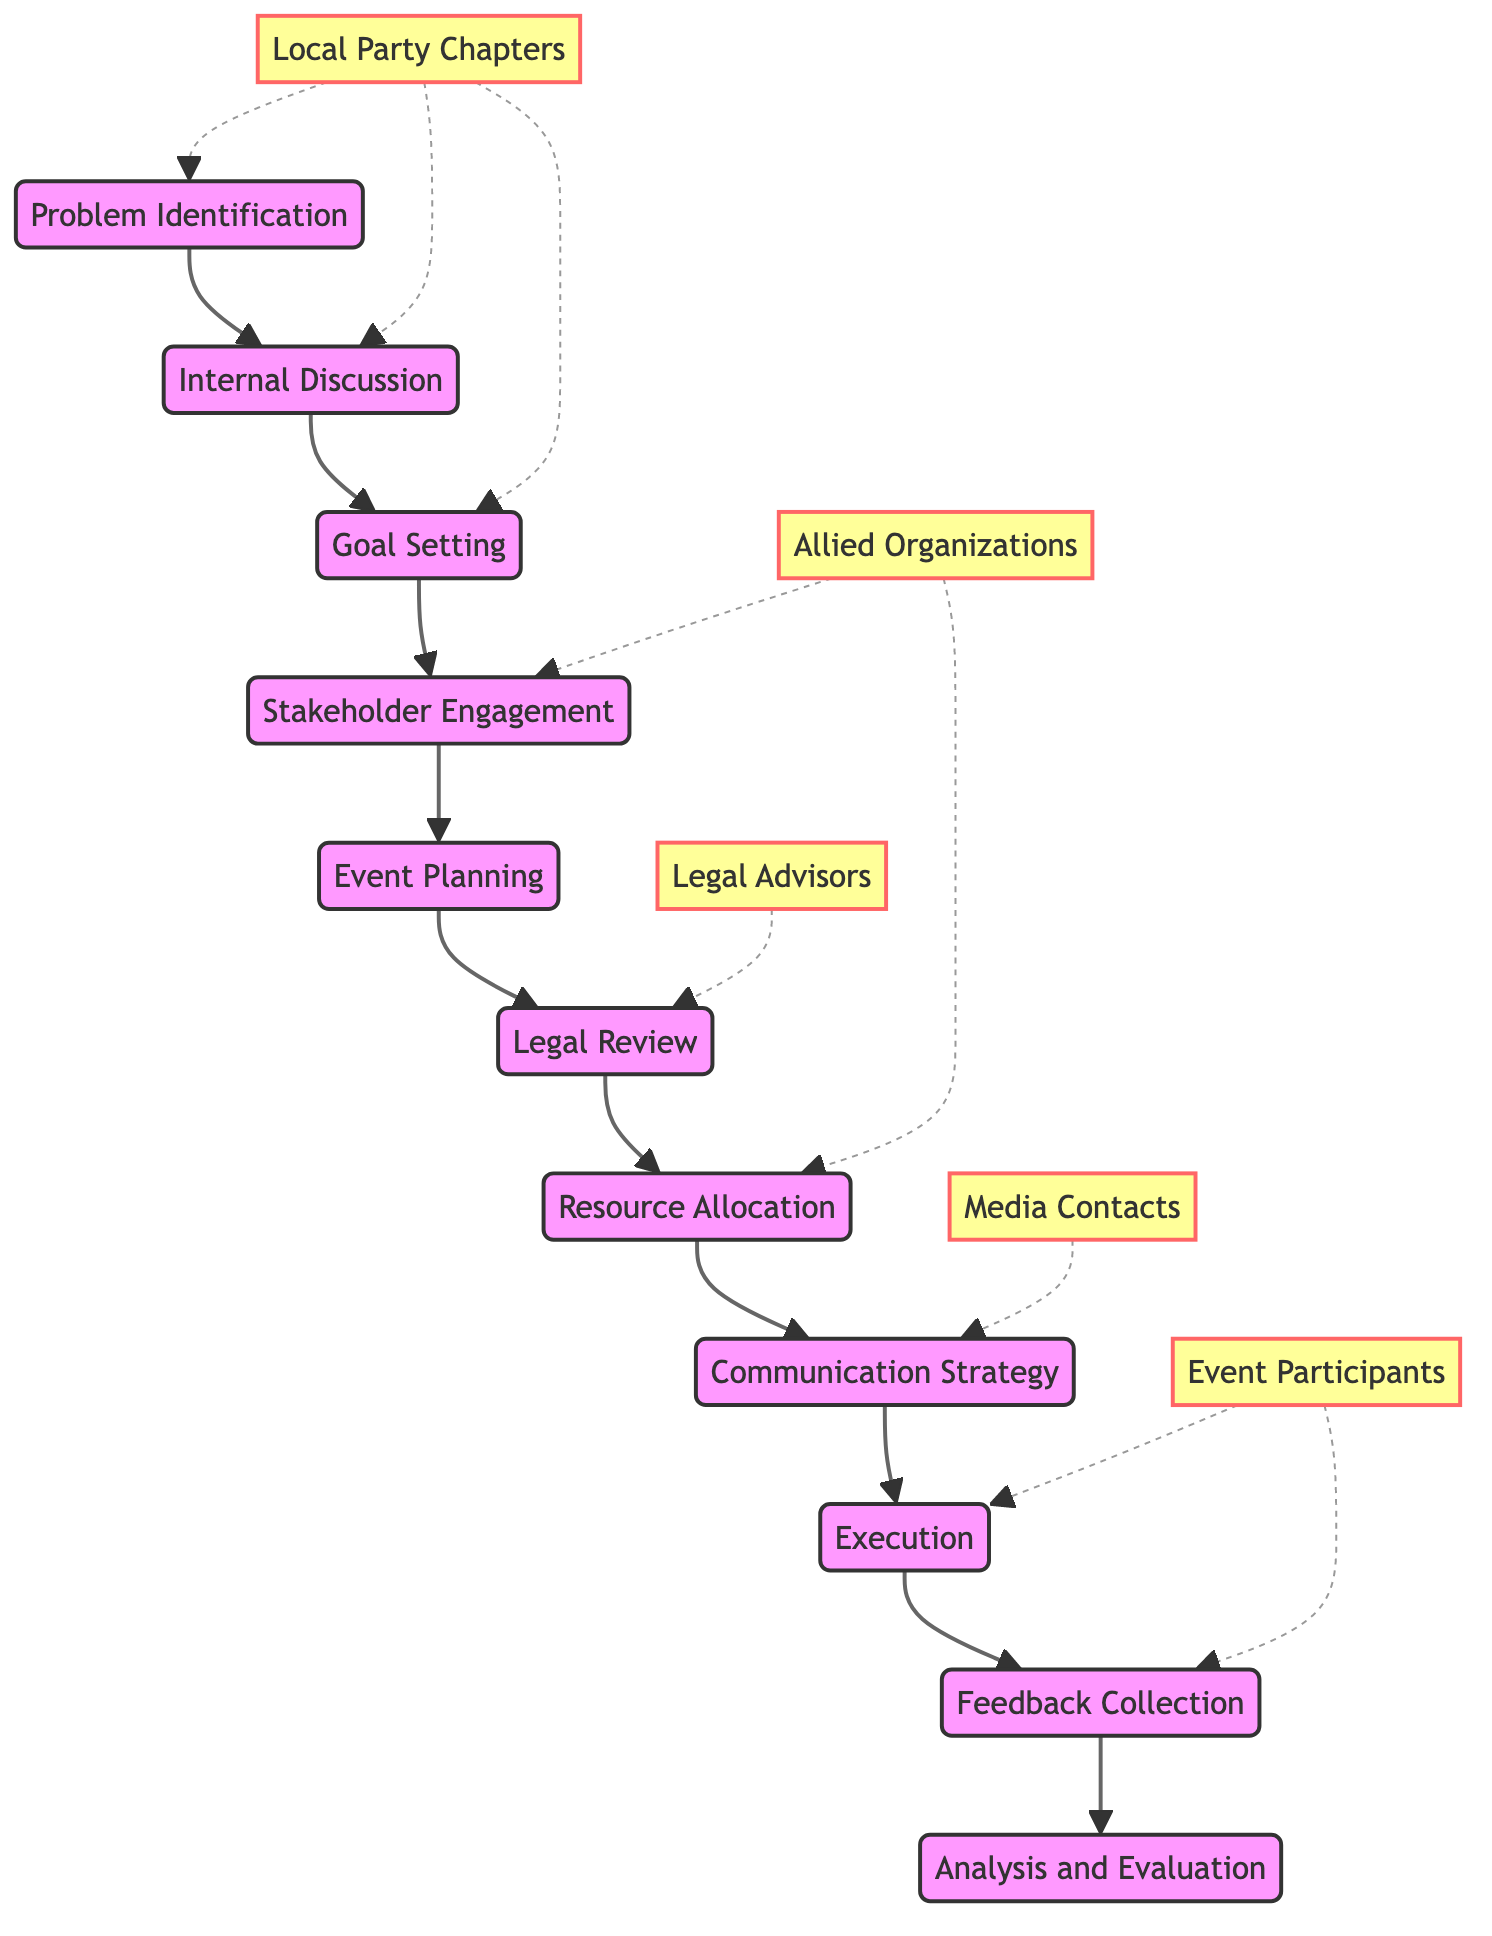What is the first step in the decision-making process? The first step, as represented by the diagram, is "Problem Identification". This is determined by looking at the starting node before any edges leading to other nodes.
Answer: Problem Identification How many stakeholders are involved in this process? By counting the distinct stakeholders listed in the diagram, there are five entities: "Local Party Chapters", "Allied Organizations", "Legal Advisors", "Media Contacts", and "Event Participants".
Answer: Five What is the last stage in the flow of the decision-making process? The last stage can be identified by following the directed edges from the first node all the way to the terminal node, which is "Analysis and Evaluation".
Answer: Analysis and Evaluation Which stakeholders are involved in the "Execution" stage? The diagram indicates that the stakeholder "Event Participants" is connected to the node "Execution", showing their involvement at this stage of the process.
Answer: Event Participants List the stages that directly precede "Communication Strategy". The stages leading to "Communication Strategy" include "Resource Allocation" and "Legal Review". This can be traced back by following the directed edges leading to the "Communication Strategy" node.
Answer: Resource Allocation, Legal Review What role do "Local Party Chapters" play in the decision-making process? "Local Party Chapters" are connected through the nodes "Problem Identification", "Internal Discussion", and "Goal Setting". This shows they are involved in the initial stages of identifying issues and setting objectives.
Answer: Problem Identification, Internal Discussion, Goal Setting Which node follows "Feedback Collection" in the diagram? In following the directed edges originating from "Feedback Collection", the next node is "Analysis and Evaluation", indicating what comes after collecting feedback.
Answer: Analysis and Evaluation Identify a stage that involves "Allied Organizations". "Stakeholder Engagement" is directly linked to "Allied Organizations", indicating their role in this stage of the decision-making process.
Answer: Stakeholder Engagement What is the relationship between "Legal Advisors" and the decision-making process? The "Legal Advisors" are directly linked to the "Legal Review" node, illustrating their involvement in reviewing the legality of the actions taken during the process.
Answer: Legal Review 